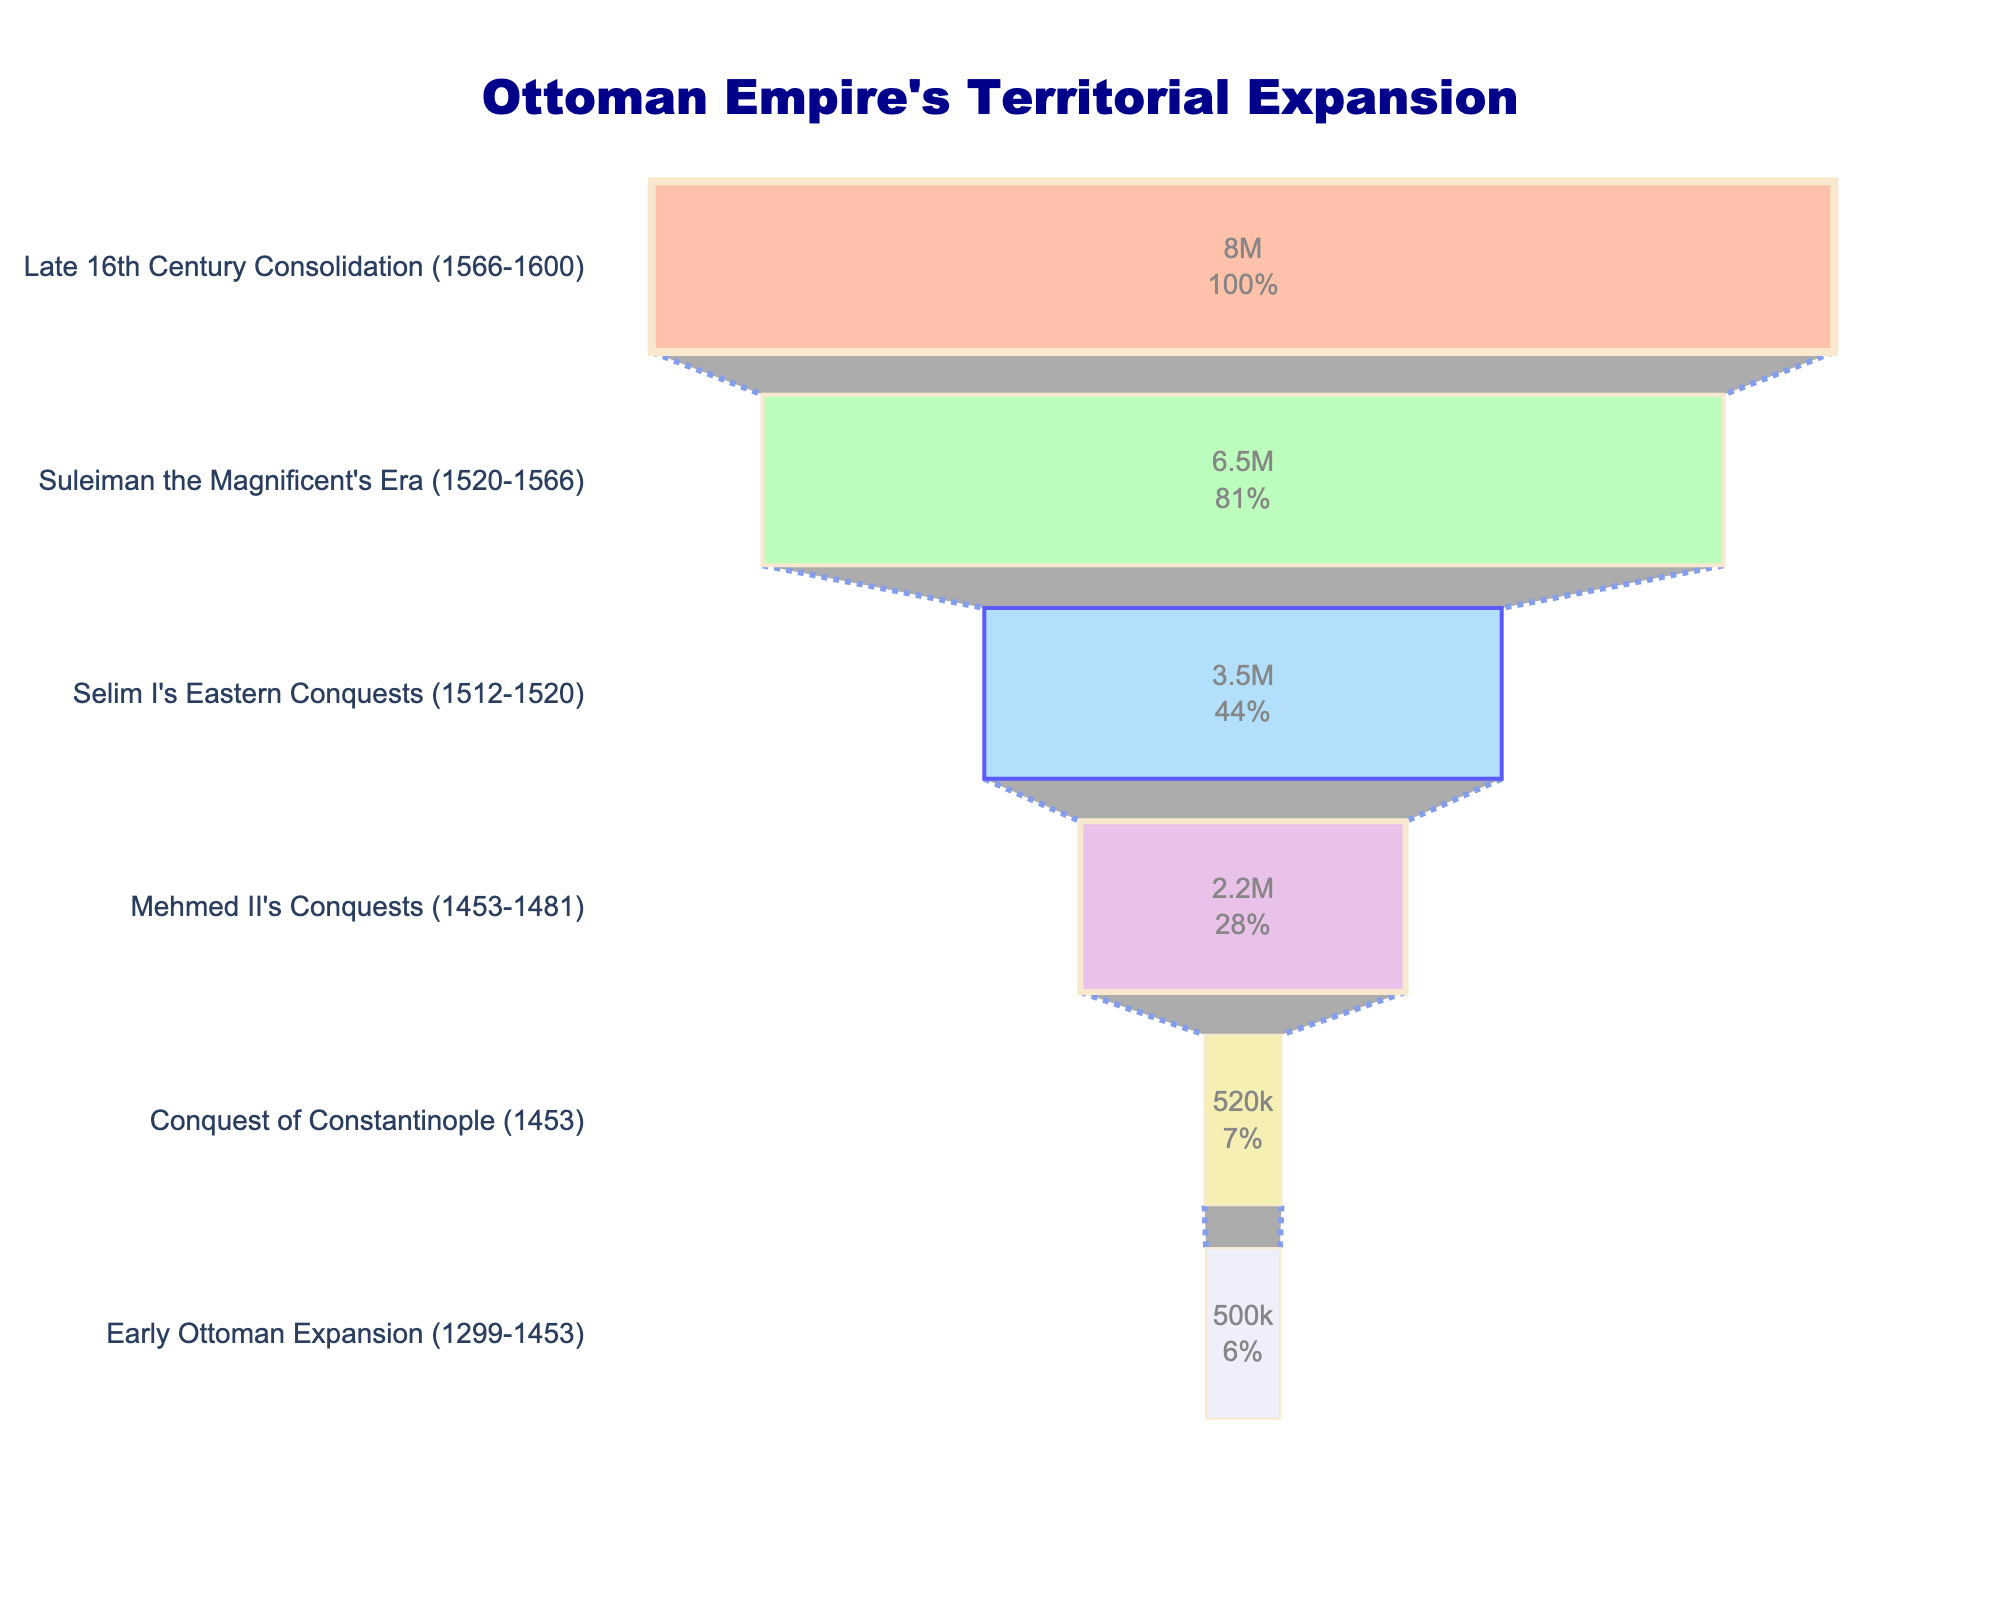What's the title of the plot? The title of the plot is displayed at the top of the funnel chart. By reading the text at the top, we can determine the title.
Answer: "Ottoman Empire's Territorial Expansion" How many phases are depicted in the chart? By counting the different phases listed on the y-axis of the funnel chart, we can determine the total number of phases.
Answer: 6 What is the smallest territorial expansion shown on the chart? The values of territorial expansion are given along the x-axis of the funnel chart. The smallest value can be identified by looking at the initial phase at the top of the chart.
Answer: 500,000 sq km By how many square kilometers did the Ottoman Empire's territory expand during Mehmed II's conquests? By locating the Mehmed II's Conquests phase on the chart and reading the value associated with it along the x-axis, we can determine the territorial expansion.
Answer: 2,200,000 sq km How much did the territory expand from the Early Ottoman Expansion to Suleiman the Magnificent's Era? To find the difference, identify the territorial expansions of both phases and subtract the earlier phase from the later phase: 6,500,000 sq km (Suleiman the Magnificent's Era) - 500,000 sq km (Early Ottoman Expansion) = 6,000,000 sq km.
Answer: 6,000,000 sq km Which phase had the highest territorial expansion? To find the phase with the highest expansion, look for the maximum value along the x-axis and find the corresponding phase on the y-axis.
Answer: Suleiman the Magnificent's Era Calculate the total territorial expansion from Selim I's Eastern Conquests to the Late 16th Century Consolidation. Sum the territorial expansions of the relevant phases: 3,500,000 sq km (Selim I's Eastern Conquests) + 6,500,000 sq km (Suleiman the Magnificent's Era) + 8,000,000 sq km (Late 16th Century Consolidation) = 18,000,000 sq km.
Answer: 18,000,000 sq km How much larger was the territorial expansion during Suleiman the Magnificent's Era compared to Selim I's Eastern Conquests? By finding the territorial expansions during both phases and subtracting Selim I's Eastern Conquests from Suleiman the Magnificent's Era: 6,500,000 sq km - 3,500,000 sq km = 3,000,000 sq km.
Answer: 3,000,000 sq km What percentage of the initial expansion does the Late 16th Century Consolidation represent? Divide the territorial expansion of the Late 16th Century Consolidation by the initial phase and multiply by 100: (8,000,000 sq km / 500,000 sq km) * 100 = 1600%.
Answer: 1600% What trend in territorial expansion is evident from the chart? By observing the sizes of the funnel chart sections, we can see the expansion values increase over time, reaching a peak during Suleiman the Magnificent's Era, and remain relatively high in later phases.
Answer: Increasing then stabilizing 